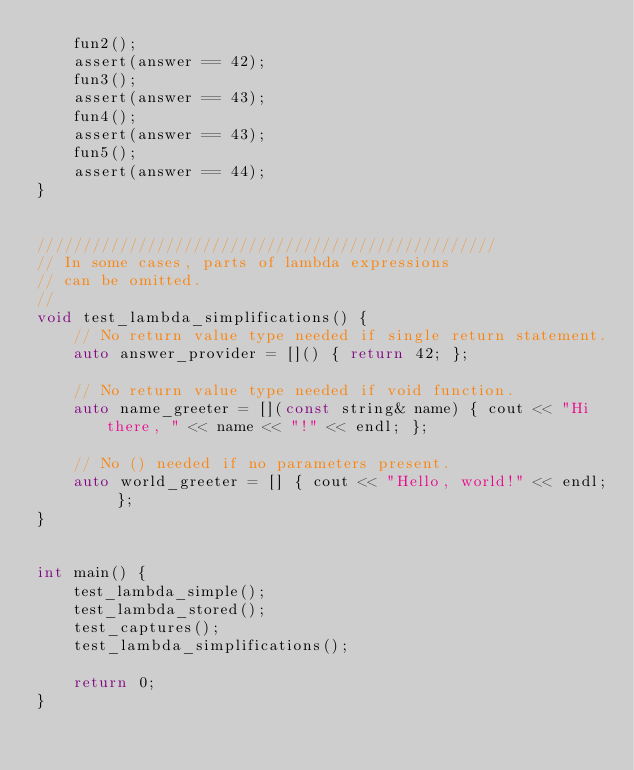<code> <loc_0><loc_0><loc_500><loc_500><_C++_>    fun2();
    assert(answer == 42);
    fun3();
    assert(answer == 43);
    fun4();
    assert(answer == 43);
    fun5();
    assert(answer == 44);
}


//////////////////////////////////////////////////
// In some cases, parts of lambda expressions
// can be omitted.
//
void test_lambda_simplifications() {
    // No return value type needed if single return statement.
    auto answer_provider = []() { return 42; };

    // No return value type needed if void function.
    auto name_greeter = [](const string& name) { cout << "Hi there, " << name << "!" << endl; };

    // No () needed if no parameters present.
    auto world_greeter = [] { cout << "Hello, world!" << endl; };
}


int main() {
    test_lambda_simple();
    test_lambda_stored();
    test_captures();
    test_lambda_simplifications();

    return 0;
}
</code> 